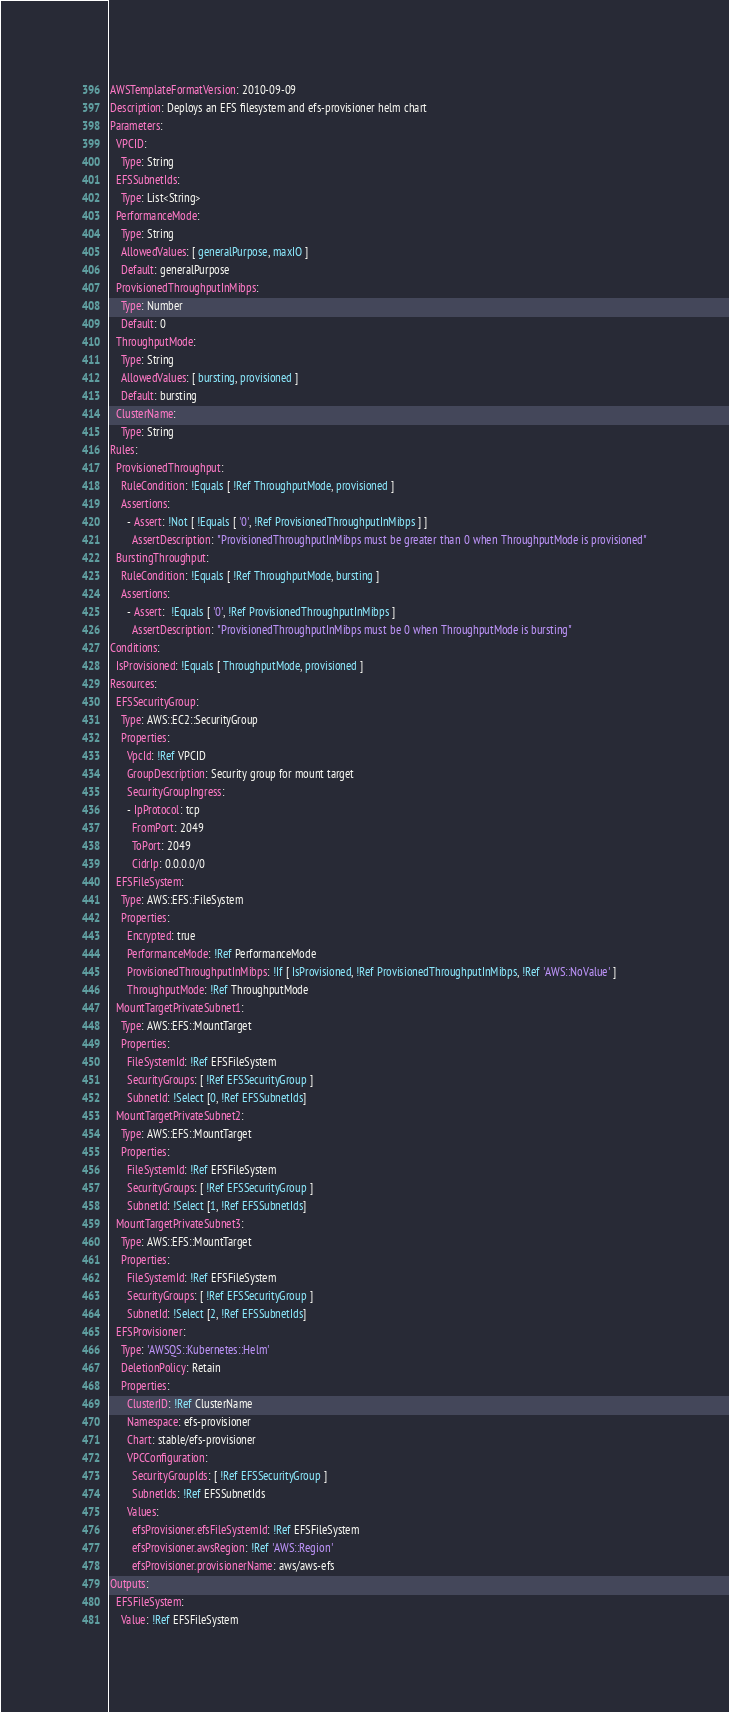<code> <loc_0><loc_0><loc_500><loc_500><_YAML_>AWSTemplateFormatVersion: 2010-09-09
Description: Deploys an EFS filesystem and efs-provisioner helm chart
Parameters:
  VPCID:
    Type: String
  EFSSubnetIds:
    Type: List<String>
  PerformanceMode:
    Type: String
    AllowedValues: [ generalPurpose, maxIO ]
    Default: generalPurpose
  ProvisionedThroughputInMibps:
    Type: Number
    Default: 0
  ThroughputMode:
    Type: String
    AllowedValues: [ bursting, provisioned ]
    Default: bursting
  ClusterName:
    Type: String
Rules:
  ProvisionedThroughput:
    RuleCondition: !Equals [ !Ref ThroughputMode, provisioned ]
    Assertions:
      - Assert: !Not [ !Equals [ '0', !Ref ProvisionedThroughputInMibps ] ]
        AssertDescription: "ProvisionedThroughputInMibps must be greater than 0 when ThroughputMode is provisioned"
  BurstingThroughput:
    RuleCondition: !Equals [ !Ref ThroughputMode, bursting ]
    Assertions:
      - Assert:  !Equals [ '0', !Ref ProvisionedThroughputInMibps ]
        AssertDescription: "ProvisionedThroughputInMibps must be 0 when ThroughputMode is bursting"
Conditions:
  IsProvisioned: !Equals [ ThroughputMode, provisioned ]
Resources:
  EFSSecurityGroup:
    Type: AWS::EC2::SecurityGroup
    Properties:
      VpcId: !Ref VPCID
      GroupDescription: Security group for mount target
      SecurityGroupIngress:
      - IpProtocol: tcp
        FromPort: 2049
        ToPort: 2049
        CidrIp: 0.0.0.0/0
  EFSFileSystem:
    Type: AWS::EFS::FileSystem
    Properties:
      Encrypted: true
      PerformanceMode: !Ref PerformanceMode
      ProvisionedThroughputInMibps: !If [ IsProvisioned, !Ref ProvisionedThroughputInMibps, !Ref 'AWS::NoValue' ]
      ThroughputMode: !Ref ThroughputMode
  MountTargetPrivateSubnet1:
    Type: AWS::EFS::MountTarget
    Properties:
      FileSystemId: !Ref EFSFileSystem
      SecurityGroups: [ !Ref EFSSecurityGroup ]
      SubnetId: !Select [0, !Ref EFSSubnetIds]
  MountTargetPrivateSubnet2:
    Type: AWS::EFS::MountTarget
    Properties:
      FileSystemId: !Ref EFSFileSystem
      SecurityGroups: [ !Ref EFSSecurityGroup ]
      SubnetId: !Select [1, !Ref EFSSubnetIds]
  MountTargetPrivateSubnet3:
    Type: AWS::EFS::MountTarget
    Properties:
      FileSystemId: !Ref EFSFileSystem
      SecurityGroups: [ !Ref EFSSecurityGroup ]
      SubnetId: !Select [2, !Ref EFSSubnetIds]
  EFSProvisioner:
    Type: 'AWSQS::Kubernetes::Helm'
    DeletionPolicy: Retain
    Properties:
      ClusterID: !Ref ClusterName
      Namespace: efs-provisioner
      Chart: stable/efs-provisioner
      VPCConfiguration:
        SecurityGroupIds: [ !Ref EFSSecurityGroup ]
        SubnetIds: !Ref EFSSubnetIds
      Values:
        efsProvisioner.efsFileSystemId: !Ref EFSFileSystem
        efsProvisioner.awsRegion: !Ref 'AWS::Region'
        efsProvisioner.provisionerName: aws/aws-efs
Outputs:
  EFSFileSystem:
    Value: !Ref EFSFileSystem
</code> 